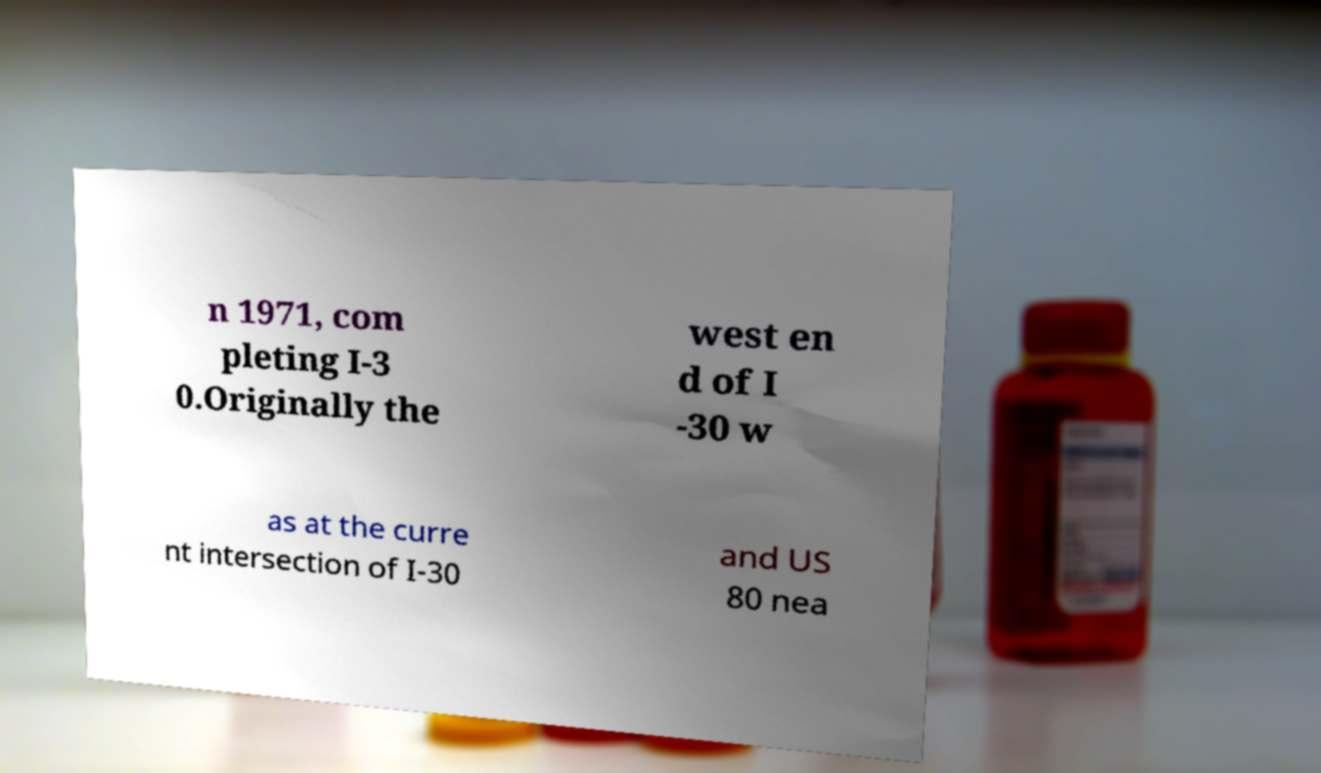Please identify and transcribe the text found in this image. n 1971, com pleting I-3 0.Originally the west en d of I -30 w as at the curre nt intersection of I-30 and US 80 nea 